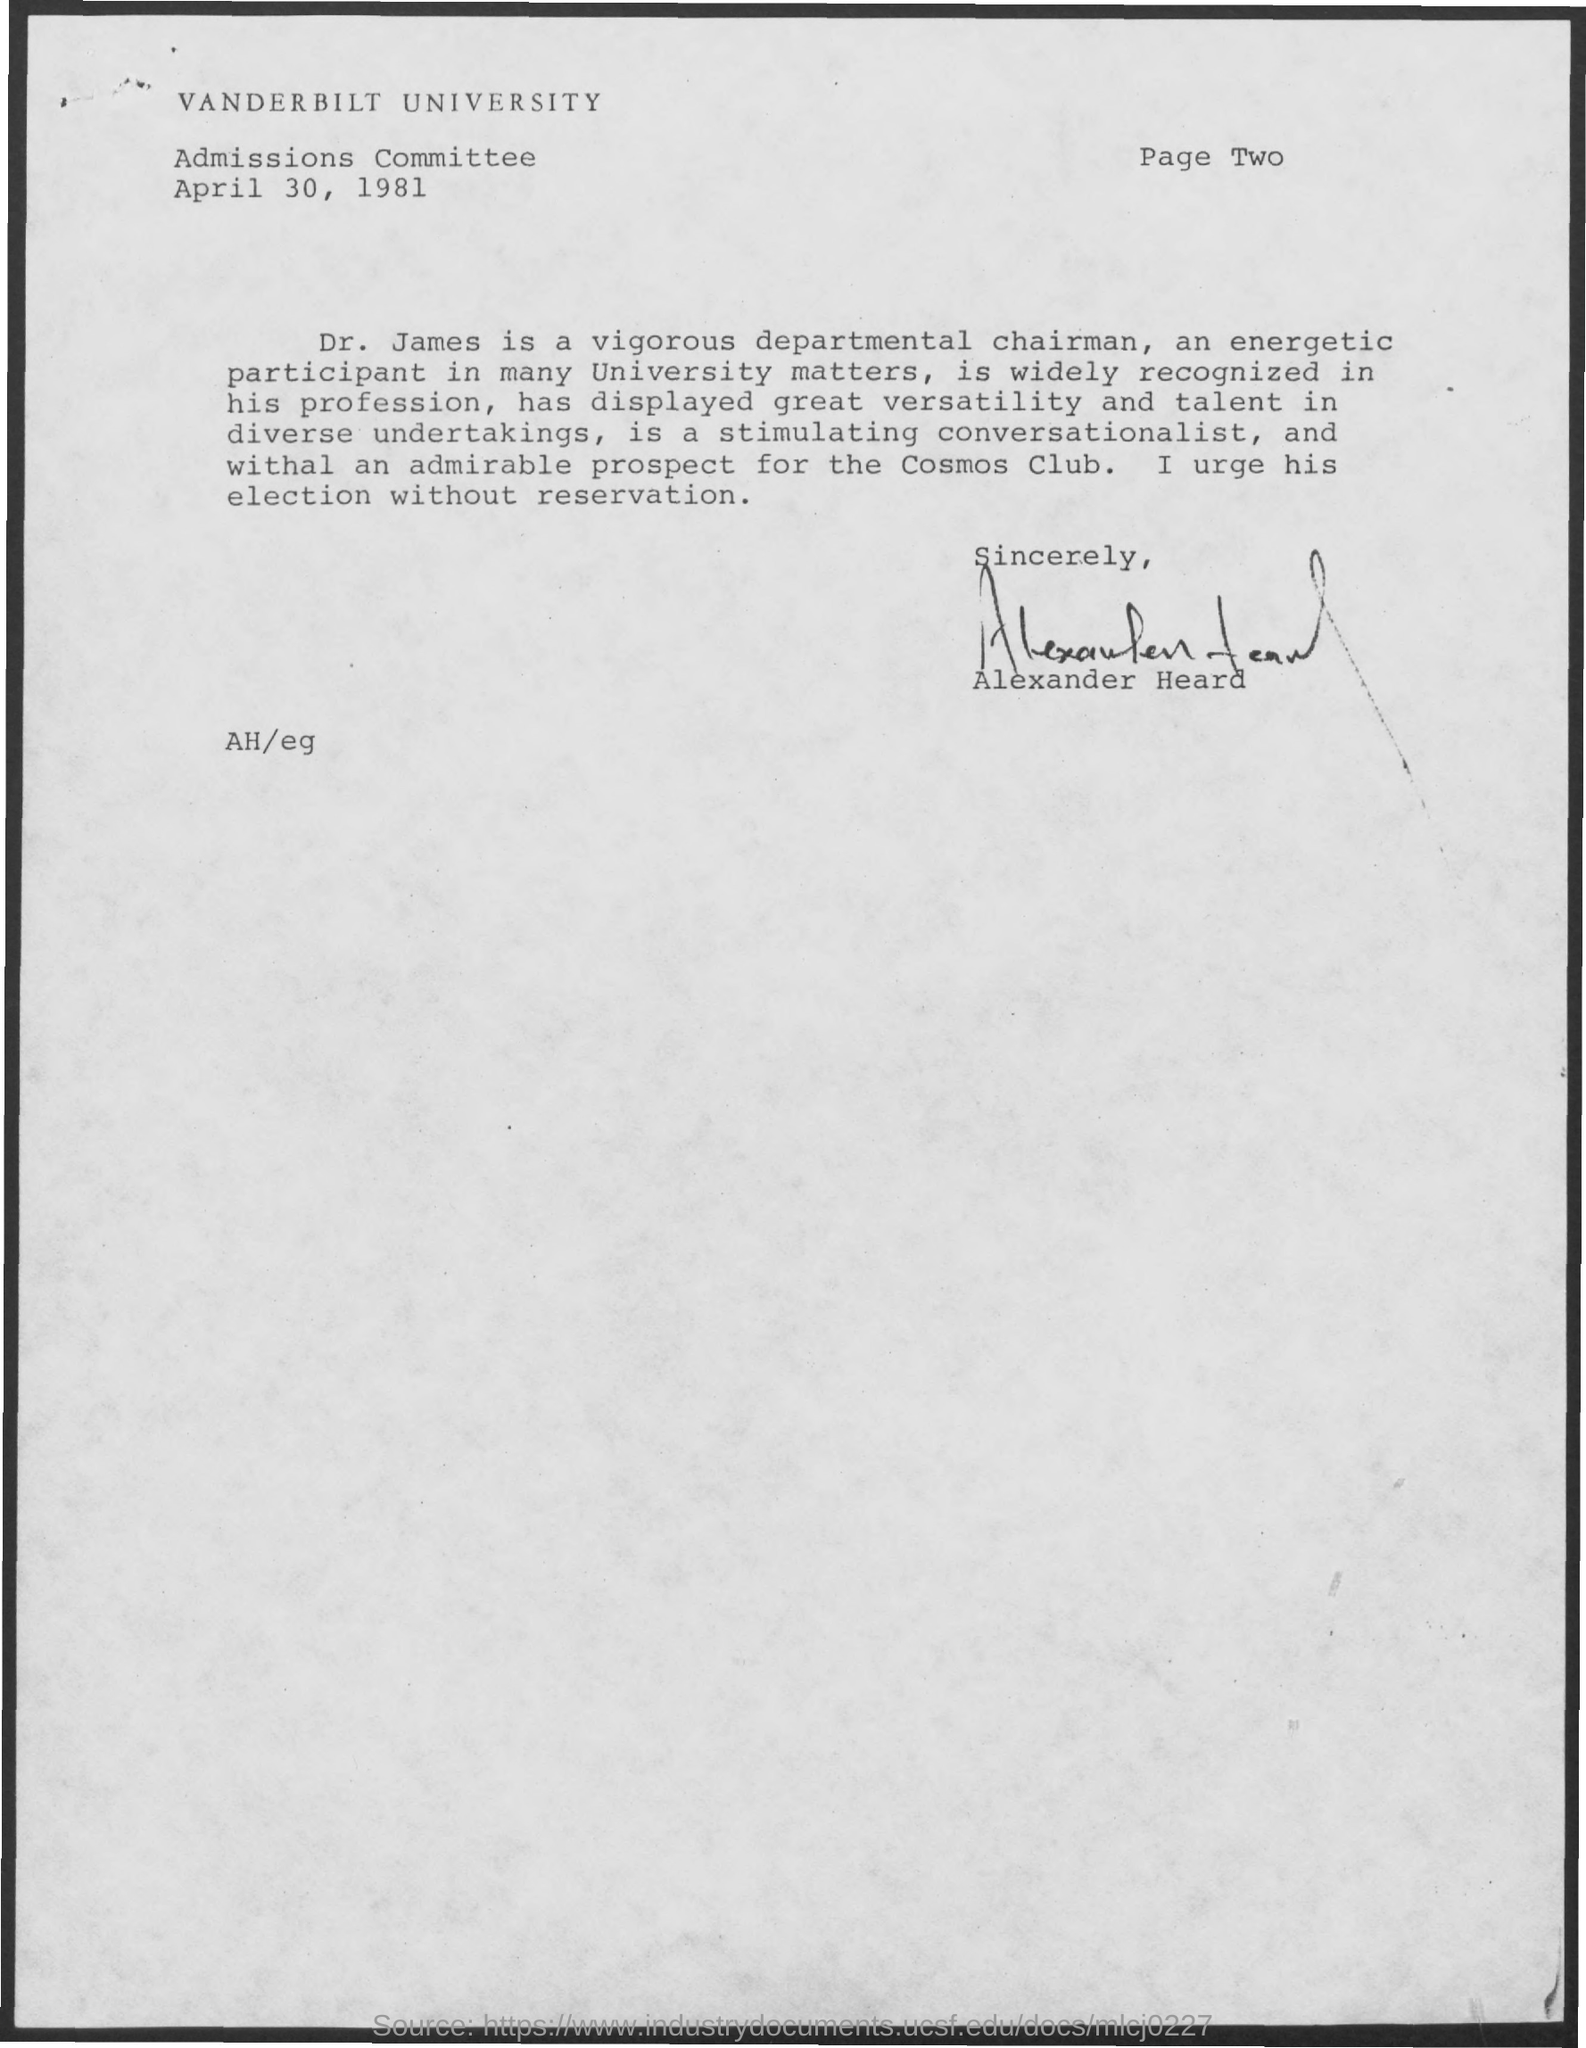Specify some key components in this picture. Vanderbilt University is the name of the university. The Memorandum is dated April 30, 1981. 